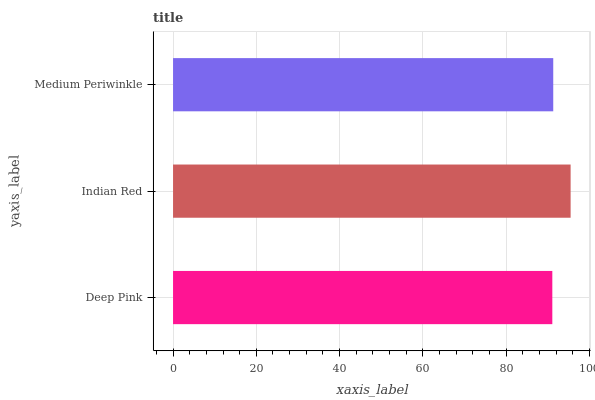Is Deep Pink the minimum?
Answer yes or no. Yes. Is Indian Red the maximum?
Answer yes or no. Yes. Is Medium Periwinkle the minimum?
Answer yes or no. No. Is Medium Periwinkle the maximum?
Answer yes or no. No. Is Indian Red greater than Medium Periwinkle?
Answer yes or no. Yes. Is Medium Periwinkle less than Indian Red?
Answer yes or no. Yes. Is Medium Periwinkle greater than Indian Red?
Answer yes or no. No. Is Indian Red less than Medium Periwinkle?
Answer yes or no. No. Is Medium Periwinkle the high median?
Answer yes or no. Yes. Is Medium Periwinkle the low median?
Answer yes or no. Yes. Is Deep Pink the high median?
Answer yes or no. No. Is Deep Pink the low median?
Answer yes or no. No. 